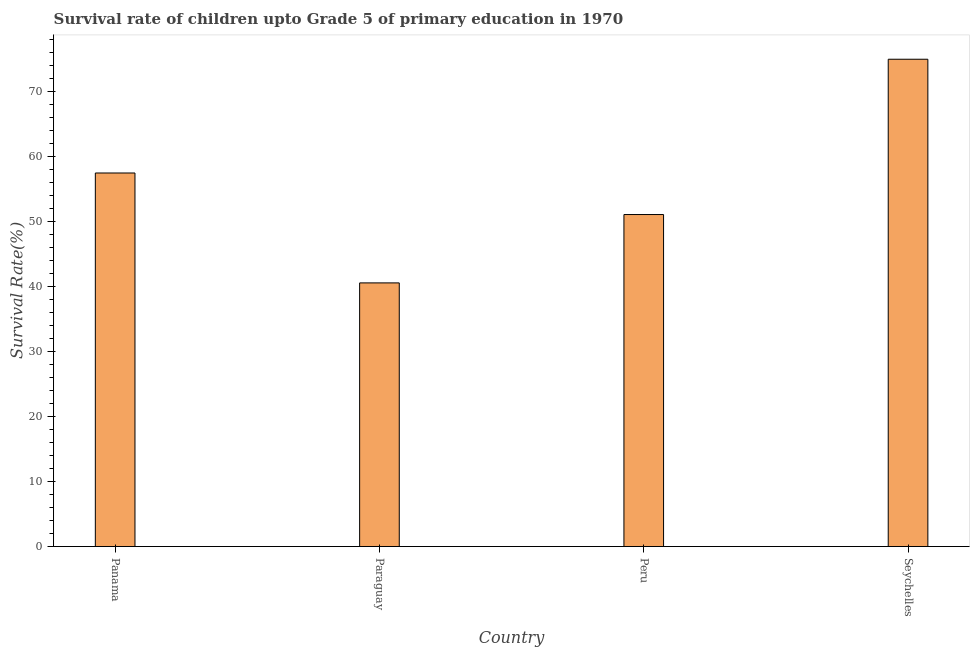Does the graph contain any zero values?
Provide a succinct answer. No. What is the title of the graph?
Your answer should be very brief. Survival rate of children upto Grade 5 of primary education in 1970 . What is the label or title of the X-axis?
Provide a short and direct response. Country. What is the label or title of the Y-axis?
Provide a succinct answer. Survival Rate(%). What is the survival rate in Seychelles?
Give a very brief answer. 74.92. Across all countries, what is the maximum survival rate?
Provide a short and direct response. 74.92. Across all countries, what is the minimum survival rate?
Your answer should be compact. 40.54. In which country was the survival rate maximum?
Make the answer very short. Seychelles. In which country was the survival rate minimum?
Your answer should be very brief. Paraguay. What is the sum of the survival rate?
Your answer should be compact. 223.93. What is the difference between the survival rate in Peru and Seychelles?
Provide a short and direct response. -23.87. What is the average survival rate per country?
Your answer should be very brief. 55.98. What is the median survival rate?
Make the answer very short. 54.24. In how many countries, is the survival rate greater than 6 %?
Keep it short and to the point. 4. What is the ratio of the survival rate in Paraguay to that in Peru?
Your answer should be very brief. 0.79. What is the difference between the highest and the second highest survival rate?
Provide a succinct answer. 17.48. What is the difference between the highest and the lowest survival rate?
Your answer should be very brief. 34.38. How many bars are there?
Keep it short and to the point. 4. How many countries are there in the graph?
Offer a very short reply. 4. What is the difference between two consecutive major ticks on the Y-axis?
Make the answer very short. 10. Are the values on the major ticks of Y-axis written in scientific E-notation?
Give a very brief answer. No. What is the Survival Rate(%) of Panama?
Your response must be concise. 57.43. What is the Survival Rate(%) of Paraguay?
Your response must be concise. 40.54. What is the Survival Rate(%) in Peru?
Keep it short and to the point. 51.04. What is the Survival Rate(%) in Seychelles?
Provide a succinct answer. 74.92. What is the difference between the Survival Rate(%) in Panama and Paraguay?
Make the answer very short. 16.9. What is the difference between the Survival Rate(%) in Panama and Peru?
Your answer should be compact. 6.39. What is the difference between the Survival Rate(%) in Panama and Seychelles?
Your response must be concise. -17.49. What is the difference between the Survival Rate(%) in Paraguay and Peru?
Your answer should be compact. -10.51. What is the difference between the Survival Rate(%) in Paraguay and Seychelles?
Provide a succinct answer. -34.38. What is the difference between the Survival Rate(%) in Peru and Seychelles?
Make the answer very short. -23.87. What is the ratio of the Survival Rate(%) in Panama to that in Paraguay?
Provide a succinct answer. 1.42. What is the ratio of the Survival Rate(%) in Panama to that in Seychelles?
Give a very brief answer. 0.77. What is the ratio of the Survival Rate(%) in Paraguay to that in Peru?
Give a very brief answer. 0.79. What is the ratio of the Survival Rate(%) in Paraguay to that in Seychelles?
Your answer should be very brief. 0.54. What is the ratio of the Survival Rate(%) in Peru to that in Seychelles?
Offer a terse response. 0.68. 